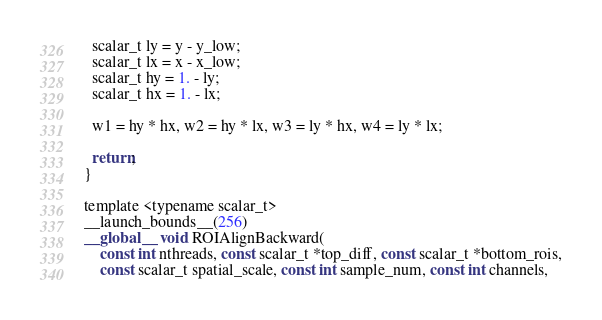Convert code to text. <code><loc_0><loc_0><loc_500><loc_500><_Cuda_>
  scalar_t ly = y - y_low;
  scalar_t lx = x - x_low;
  scalar_t hy = 1. - ly;
  scalar_t hx = 1. - lx;

  w1 = hy * hx, w2 = hy * lx, w3 = ly * hx, w4 = ly * lx;

  return;
}

template <typename scalar_t>
__launch_bounds__(256)
__global__ void ROIAlignBackward(
    const int nthreads, const scalar_t *top_diff, const scalar_t *bottom_rois,
    const scalar_t spatial_scale, const int sample_num, const int channels,</code> 